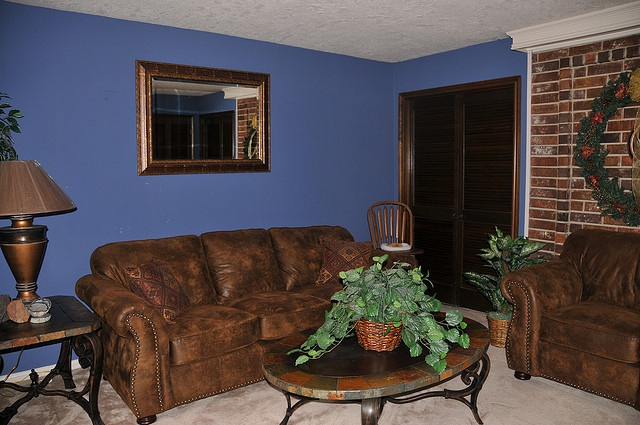Describe the objects in this image and their specific colors. I can see couch in navy, maroon, black, and brown tones, couch in navy, black, maroon, and gray tones, potted plant in navy, darkgreen, black, and green tones, potted plant in navy, black, gray, maroon, and darkgreen tones, and chair in navy, black, maroon, and darkblue tones in this image. 